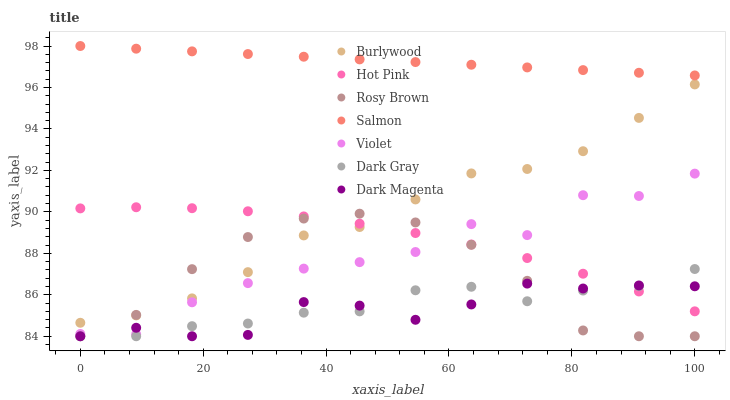Does Dark Magenta have the minimum area under the curve?
Answer yes or no. Yes. Does Salmon have the maximum area under the curve?
Answer yes or no. Yes. Does Burlywood have the minimum area under the curve?
Answer yes or no. No. Does Burlywood have the maximum area under the curve?
Answer yes or no. No. Is Salmon the smoothest?
Answer yes or no. Yes. Is Violet the roughest?
Answer yes or no. Yes. Is Dark Magenta the smoothest?
Answer yes or no. No. Is Dark Magenta the roughest?
Answer yes or no. No. Does Dark Magenta have the lowest value?
Answer yes or no. Yes. Does Burlywood have the lowest value?
Answer yes or no. No. Does Salmon have the highest value?
Answer yes or no. Yes. Does Burlywood have the highest value?
Answer yes or no. No. Is Hot Pink less than Salmon?
Answer yes or no. Yes. Is Salmon greater than Violet?
Answer yes or no. Yes. Does Hot Pink intersect Rosy Brown?
Answer yes or no. Yes. Is Hot Pink less than Rosy Brown?
Answer yes or no. No. Is Hot Pink greater than Rosy Brown?
Answer yes or no. No. Does Hot Pink intersect Salmon?
Answer yes or no. No. 